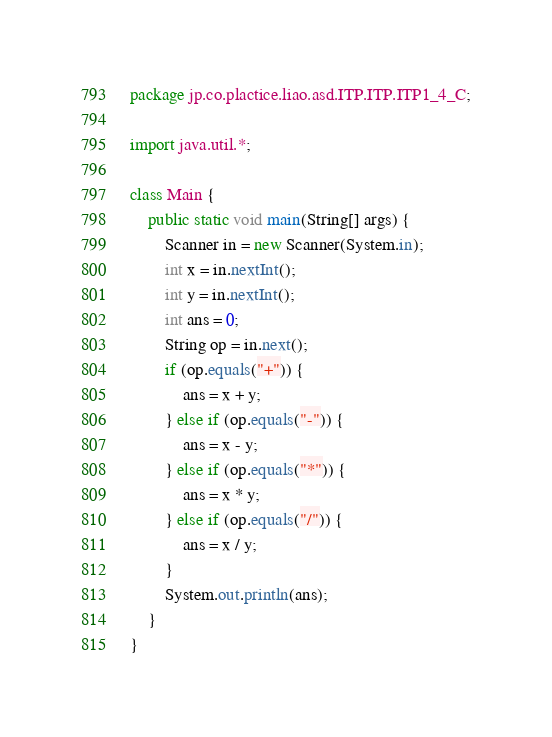Convert code to text. <code><loc_0><loc_0><loc_500><loc_500><_Java_>package jp.co.plactice.liao.asd.ITP.ITP.ITP1_4_C;

import java.util.*;

class Main {
    public static void main(String[] args) {
        Scanner in = new Scanner(System.in);
        int x = in.nextInt();
        int y = in.nextInt();
        int ans = 0;
        String op = in.next();
        if (op.equals("+")) {
            ans = x + y;
        } else if (op.equals("-")) {
            ans = x - y;
        } else if (op.equals("*")) {
            ans = x * y;
        } else if (op.equals("/")) {
            ans = x / y;
        }
        System.out.println(ans);
    }
}</code> 